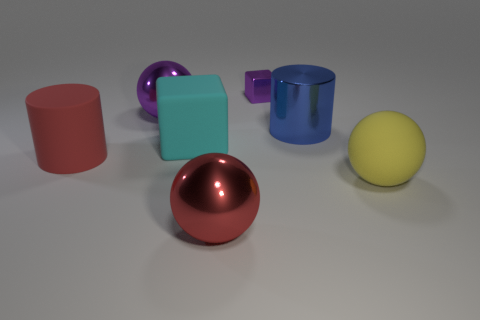What number of red matte blocks are there?
Provide a succinct answer. 0. What is the color of the shiny ball behind the big cylinder right of the red metallic ball?
Your answer should be very brief. Purple. There is a shiny cylinder that is the same size as the red matte object; what color is it?
Your answer should be very brief. Blue. Are there any big matte cylinders that have the same color as the tiny metallic cube?
Your answer should be compact. No. Are there any blue blocks?
Ensure brevity in your answer.  No. There is a red thing behind the big red metallic thing; what shape is it?
Make the answer very short. Cylinder. What number of big cylinders are on the left side of the big red metal sphere and right of the cyan block?
Provide a short and direct response. 0. What number of other objects are the same size as the yellow sphere?
Provide a succinct answer. 5. There is a purple object right of the red shiny thing; is it the same shape as the big metallic thing that is behind the large metallic cylinder?
Your answer should be compact. No. What number of things are brown cubes or large balls behind the cyan rubber thing?
Give a very brief answer. 1. 